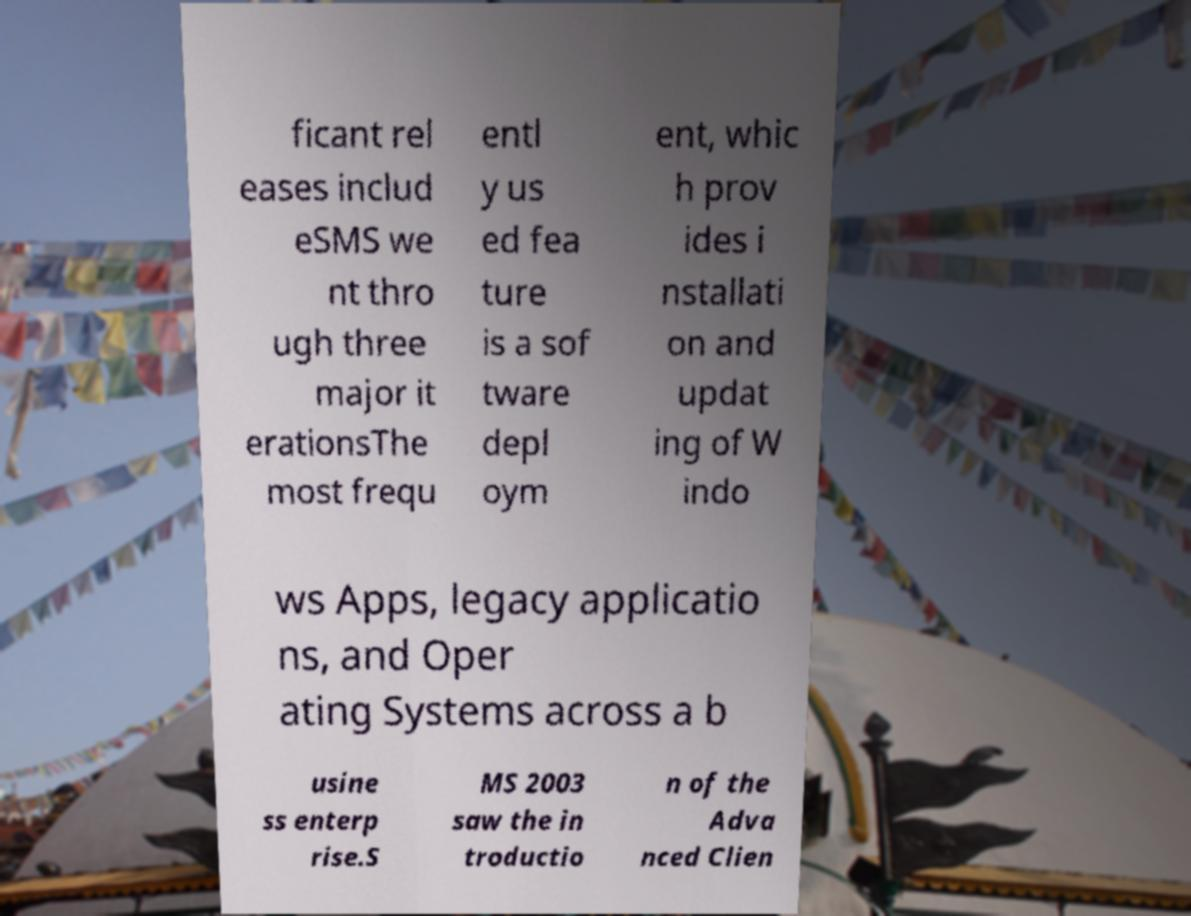There's text embedded in this image that I need extracted. Can you transcribe it verbatim? ficant rel eases includ eSMS we nt thro ugh three major it erationsThe most frequ entl y us ed fea ture is a sof tware depl oym ent, whic h prov ides i nstallati on and updat ing of W indo ws Apps, legacy applicatio ns, and Oper ating Systems across a b usine ss enterp rise.S MS 2003 saw the in troductio n of the Adva nced Clien 